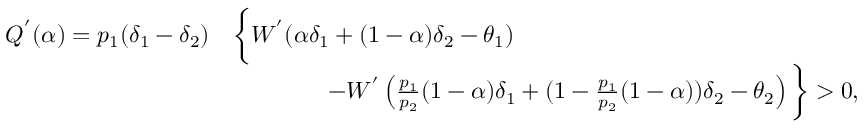<formula> <loc_0><loc_0><loc_500><loc_500>\begin{array} { r l } { Q ^ { ^ { \prime } } ( \alpha ) = p _ { 1 } ( \delta _ { 1 } - \delta _ { 2 } ) } & { \left \{ W ^ { ^ { \prime } } ( \alpha \delta _ { 1 } + ( 1 - \alpha ) \delta _ { 2 } - \theta _ { 1 } ) } \\ & { \quad - W ^ { ^ { \prime } } \left ( \frac { p _ { 1 } } { p _ { 2 } } ( 1 - \alpha ) \delta _ { 1 } + ( 1 - \frac { p _ { 1 } } { p _ { 2 } } ( 1 - \alpha ) ) \delta _ { 2 } - \theta _ { 2 } \right ) \right \} > 0 , } \end{array}</formula> 